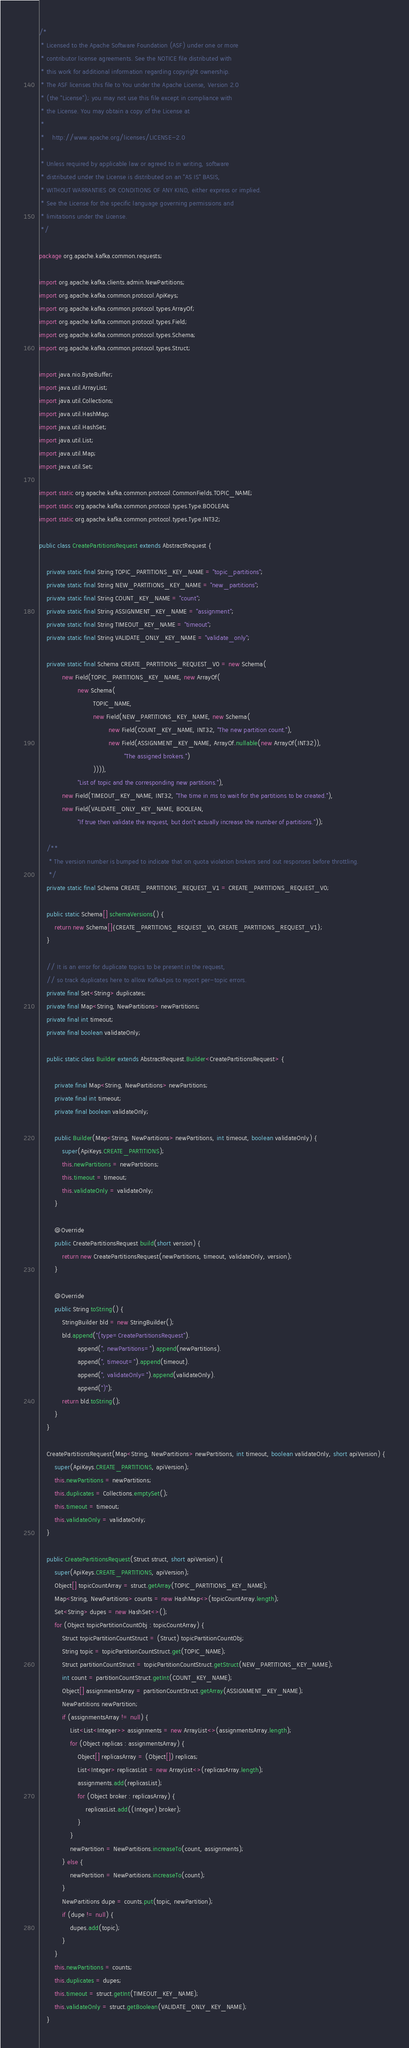<code> <loc_0><loc_0><loc_500><loc_500><_Java_>/*
 * Licensed to the Apache Software Foundation (ASF) under one or more
 * contributor license agreements. See the NOTICE file distributed with
 * this work for additional information regarding copyright ownership.
 * The ASF licenses this file to You under the Apache License, Version 2.0
 * (the "License"); you may not use this file except in compliance with
 * the License. You may obtain a copy of the License at
 *
 *    http://www.apache.org/licenses/LICENSE-2.0
 *
 * Unless required by applicable law or agreed to in writing, software
 * distributed under the License is distributed on an "AS IS" BASIS,
 * WITHOUT WARRANTIES OR CONDITIONS OF ANY KIND, either express or implied.
 * See the License for the specific language governing permissions and
 * limitations under the License.
 */

package org.apache.kafka.common.requests;

import org.apache.kafka.clients.admin.NewPartitions;
import org.apache.kafka.common.protocol.ApiKeys;
import org.apache.kafka.common.protocol.types.ArrayOf;
import org.apache.kafka.common.protocol.types.Field;
import org.apache.kafka.common.protocol.types.Schema;
import org.apache.kafka.common.protocol.types.Struct;

import java.nio.ByteBuffer;
import java.util.ArrayList;
import java.util.Collections;
import java.util.HashMap;
import java.util.HashSet;
import java.util.List;
import java.util.Map;
import java.util.Set;

import static org.apache.kafka.common.protocol.CommonFields.TOPIC_NAME;
import static org.apache.kafka.common.protocol.types.Type.BOOLEAN;
import static org.apache.kafka.common.protocol.types.Type.INT32;

public class CreatePartitionsRequest extends AbstractRequest {

    private static final String TOPIC_PARTITIONS_KEY_NAME = "topic_partitions";
    private static final String NEW_PARTITIONS_KEY_NAME = "new_partitions";
    private static final String COUNT_KEY_NAME = "count";
    private static final String ASSIGNMENT_KEY_NAME = "assignment";
    private static final String TIMEOUT_KEY_NAME = "timeout";
    private static final String VALIDATE_ONLY_KEY_NAME = "validate_only";

    private static final Schema CREATE_PARTITIONS_REQUEST_V0 = new Schema(
            new Field(TOPIC_PARTITIONS_KEY_NAME, new ArrayOf(
                    new Schema(
                            TOPIC_NAME,
                            new Field(NEW_PARTITIONS_KEY_NAME, new Schema(
                                    new Field(COUNT_KEY_NAME, INT32, "The new partition count."),
                                    new Field(ASSIGNMENT_KEY_NAME, ArrayOf.nullable(new ArrayOf(INT32)),
                                            "The assigned brokers.")
                            )))),
                    "List of topic and the corresponding new partitions."),
            new Field(TIMEOUT_KEY_NAME, INT32, "The time in ms to wait for the partitions to be created."),
            new Field(VALIDATE_ONLY_KEY_NAME, BOOLEAN,
                    "If true then validate the request, but don't actually increase the number of partitions."));

    /**
     * The version number is bumped to indicate that on quota violation brokers send out responses before throttling.
     */
    private static final Schema CREATE_PARTITIONS_REQUEST_V1 = CREATE_PARTITIONS_REQUEST_V0;

    public static Schema[] schemaVersions() {
        return new Schema[]{CREATE_PARTITIONS_REQUEST_V0, CREATE_PARTITIONS_REQUEST_V1};
    }

    // It is an error for duplicate topics to be present in the request,
    // so track duplicates here to allow KafkaApis to report per-topic errors.
    private final Set<String> duplicates;
    private final Map<String, NewPartitions> newPartitions;
    private final int timeout;
    private final boolean validateOnly;

    public static class Builder extends AbstractRequest.Builder<CreatePartitionsRequest> {

        private final Map<String, NewPartitions> newPartitions;
        private final int timeout;
        private final boolean validateOnly;

        public Builder(Map<String, NewPartitions> newPartitions, int timeout, boolean validateOnly) {
            super(ApiKeys.CREATE_PARTITIONS);
            this.newPartitions = newPartitions;
            this.timeout = timeout;
            this.validateOnly = validateOnly;
        }

        @Override
        public CreatePartitionsRequest build(short version) {
            return new CreatePartitionsRequest(newPartitions, timeout, validateOnly, version);
        }

        @Override
        public String toString() {
            StringBuilder bld = new StringBuilder();
            bld.append("(type=CreatePartitionsRequest").
                    append(", newPartitions=").append(newPartitions).
                    append(", timeout=").append(timeout).
                    append(", validateOnly=").append(validateOnly).
                    append(")");
            return bld.toString();
        }
    }

    CreatePartitionsRequest(Map<String, NewPartitions> newPartitions, int timeout, boolean validateOnly, short apiVersion) {
        super(ApiKeys.CREATE_PARTITIONS, apiVersion);
        this.newPartitions = newPartitions;
        this.duplicates = Collections.emptySet();
        this.timeout = timeout;
        this.validateOnly = validateOnly;
    }

    public CreatePartitionsRequest(Struct struct, short apiVersion) {
        super(ApiKeys.CREATE_PARTITIONS, apiVersion);
        Object[] topicCountArray = struct.getArray(TOPIC_PARTITIONS_KEY_NAME);
        Map<String, NewPartitions> counts = new HashMap<>(topicCountArray.length);
        Set<String> dupes = new HashSet<>();
        for (Object topicPartitionCountObj : topicCountArray) {
            Struct topicPartitionCountStruct = (Struct) topicPartitionCountObj;
            String topic = topicPartitionCountStruct.get(TOPIC_NAME);
            Struct partitionCountStruct = topicPartitionCountStruct.getStruct(NEW_PARTITIONS_KEY_NAME);
            int count = partitionCountStruct.getInt(COUNT_KEY_NAME);
            Object[] assignmentsArray = partitionCountStruct.getArray(ASSIGNMENT_KEY_NAME);
            NewPartitions newPartition;
            if (assignmentsArray != null) {
                List<List<Integer>> assignments = new ArrayList<>(assignmentsArray.length);
                for (Object replicas : assignmentsArray) {
                    Object[] replicasArray = (Object[]) replicas;
                    List<Integer> replicasList = new ArrayList<>(replicasArray.length);
                    assignments.add(replicasList);
                    for (Object broker : replicasArray) {
                        replicasList.add((Integer) broker);
                    }
                }
                newPartition = NewPartitions.increaseTo(count, assignments);
            } else {
                newPartition = NewPartitions.increaseTo(count);
            }
            NewPartitions dupe = counts.put(topic, newPartition);
            if (dupe != null) {
                dupes.add(topic);
            }
        }
        this.newPartitions = counts;
        this.duplicates = dupes;
        this.timeout = struct.getInt(TIMEOUT_KEY_NAME);
        this.validateOnly = struct.getBoolean(VALIDATE_ONLY_KEY_NAME);
    }
</code> 